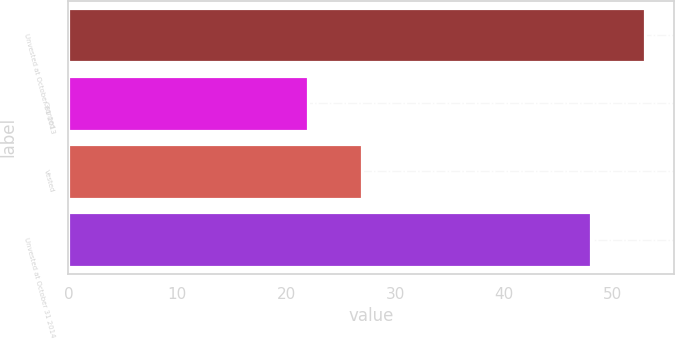Convert chart to OTSL. <chart><loc_0><loc_0><loc_500><loc_500><bar_chart><fcel>Unvested at October 31 2013<fcel>Granted<fcel>Vested<fcel>Unvested at October 31 2014<nl><fcel>53<fcel>22<fcel>27<fcel>48<nl></chart> 